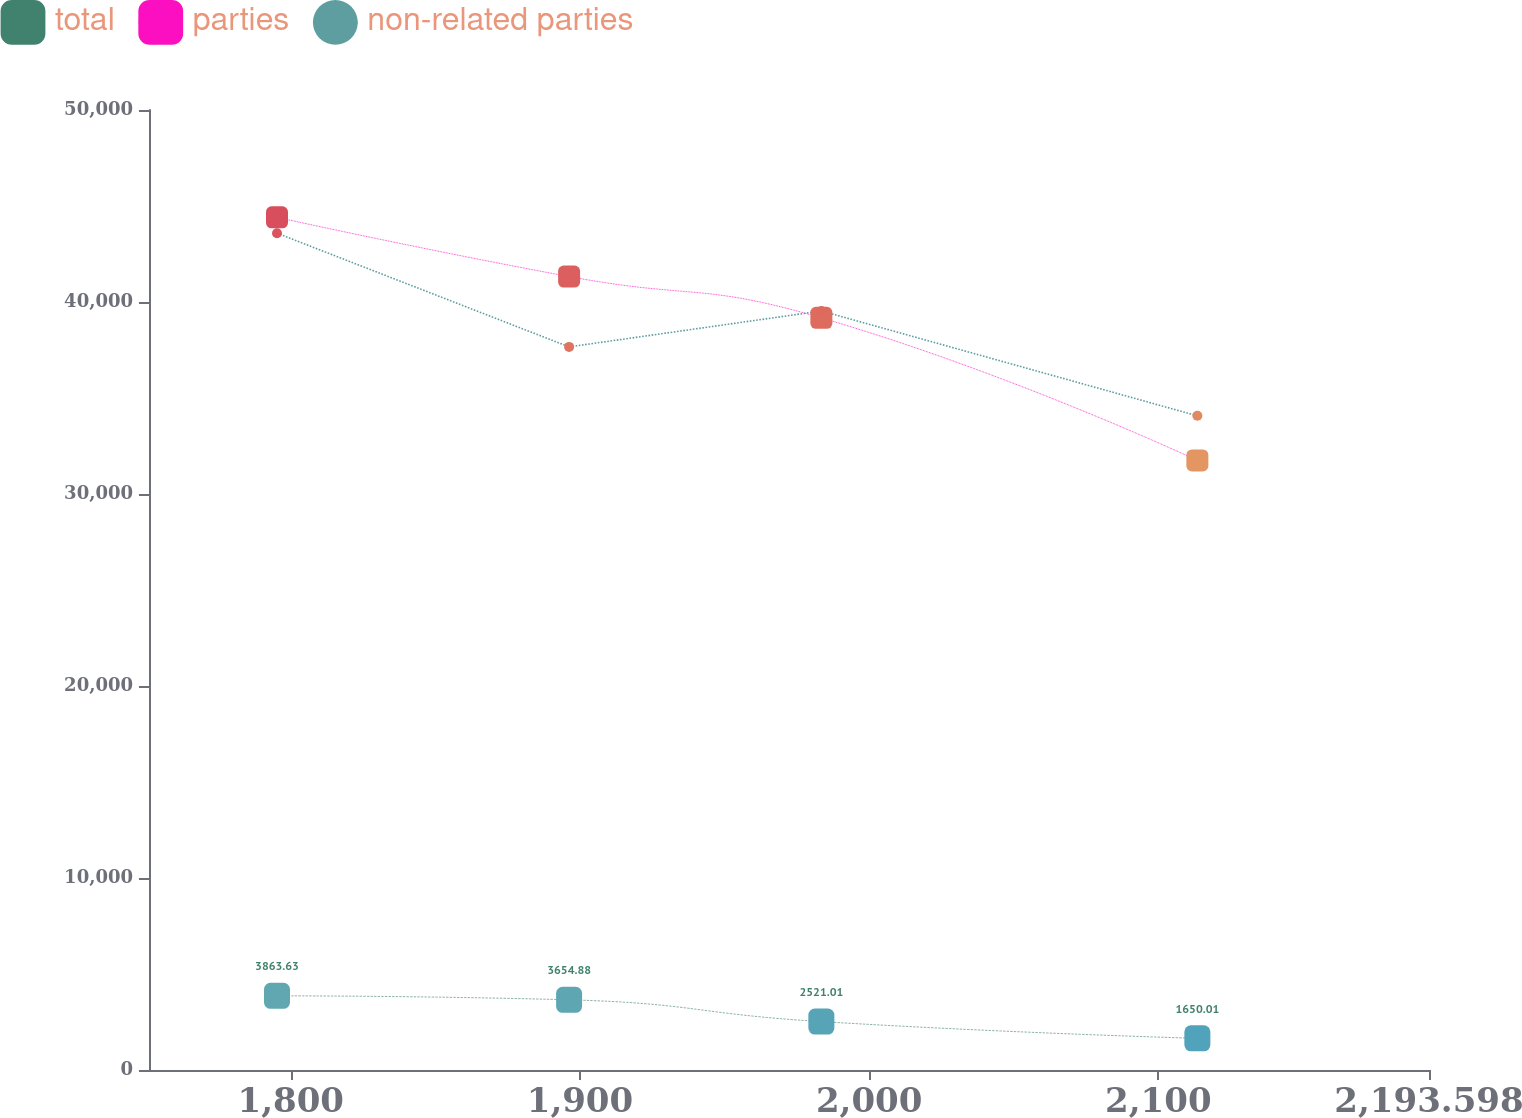Convert chart. <chart><loc_0><loc_0><loc_500><loc_500><line_chart><ecel><fcel>total<fcel>parties<fcel>non-related parties<nl><fcel>1795.24<fcel>3863.63<fcel>44410<fcel>43582<nl><fcel>1896.25<fcel>3654.88<fcel>41325.3<fcel>37662<nl><fcel>1983.48<fcel>2521.01<fcel>39173.5<fcel>39533.2<nl><fcel>2113.5<fcel>1650.01<fcel>31749.2<fcel>34071<nl><fcel>2237.86<fcel>1858.76<fcel>22892.2<fcel>24869.4<nl></chart> 